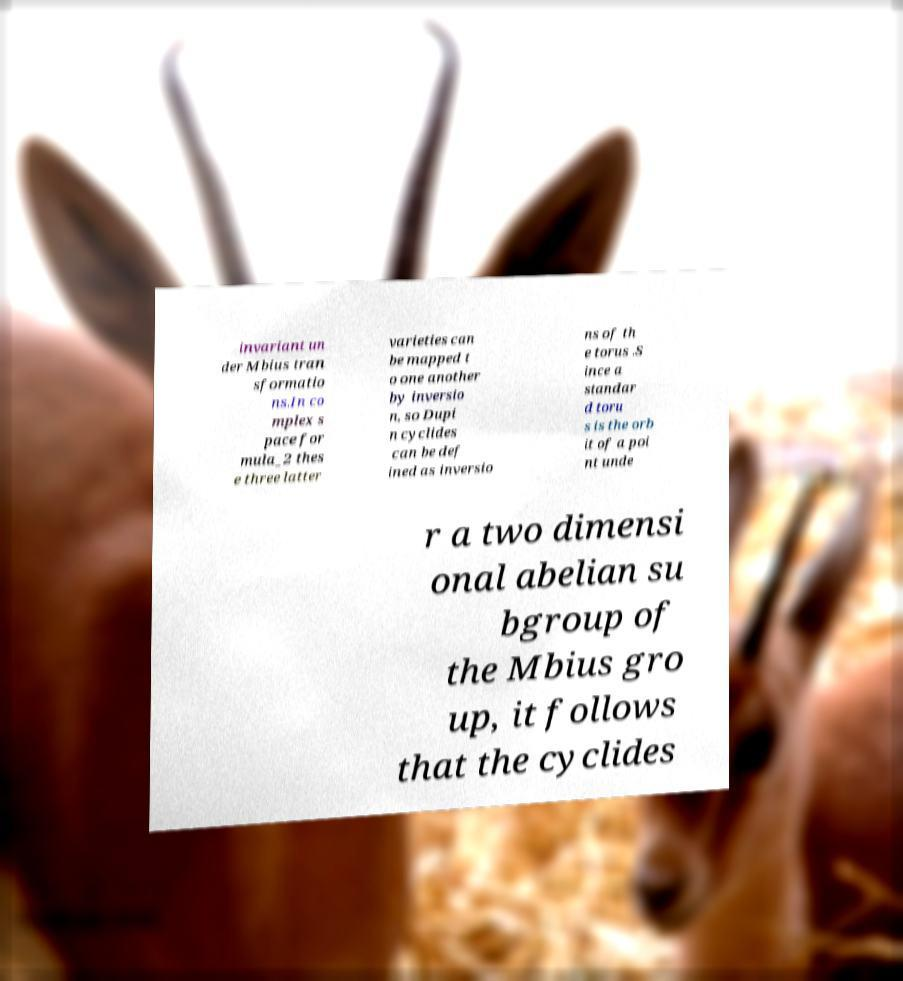Please read and relay the text visible in this image. What does it say? invariant un der Mbius tran sformatio ns.In co mplex s pace for mula_2 thes e three latter varieties can be mapped t o one another by inversio n, so Dupi n cyclides can be def ined as inversio ns of th e torus .S ince a standar d toru s is the orb it of a poi nt unde r a two dimensi onal abelian su bgroup of the Mbius gro up, it follows that the cyclides 